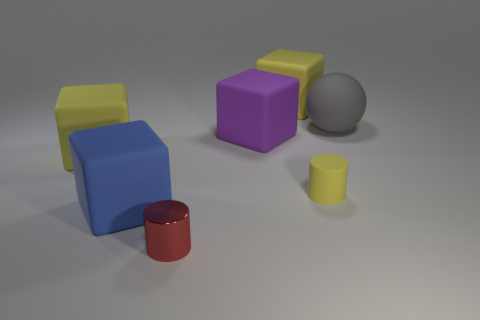Is the number of cylinders less than the number of tiny gray blocks? Indeed, there is only one cylinder present in the image, which is less than the two small gray blocks adjacent to the colorful shapes. 